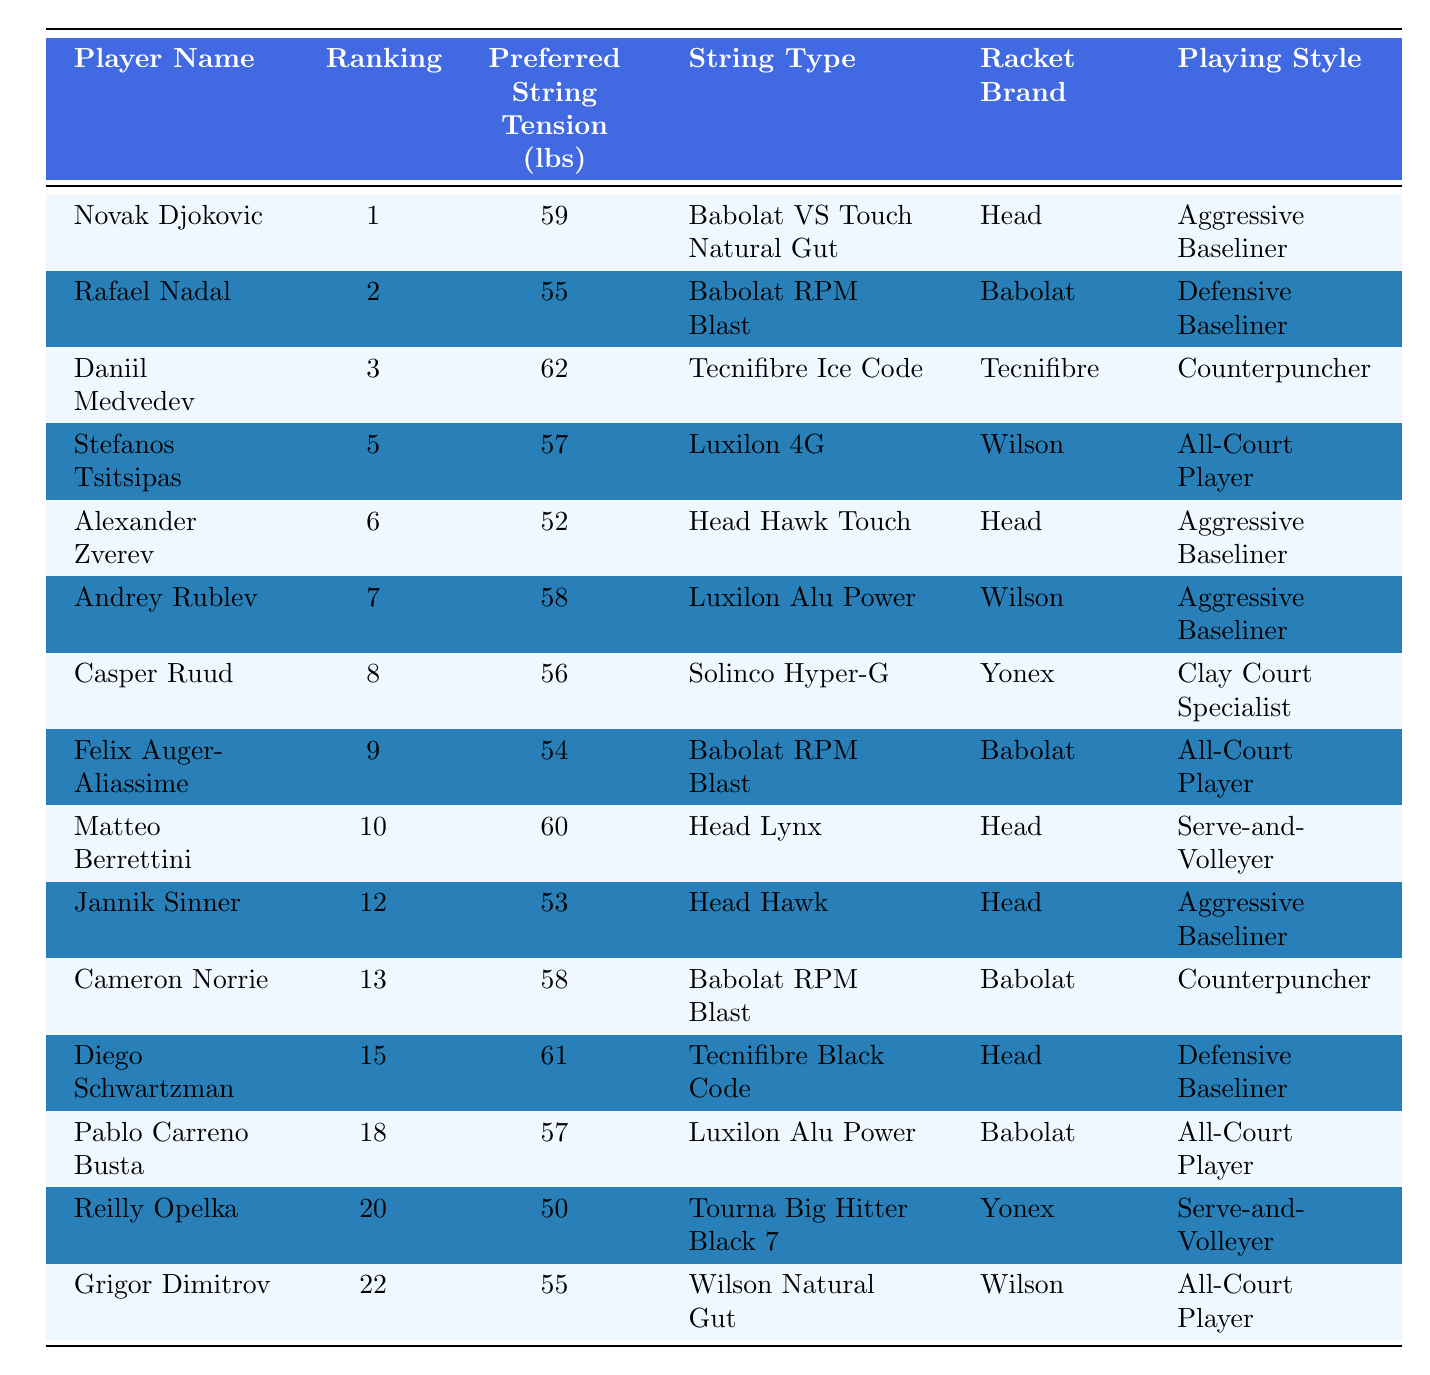What is the preferred string tension of Daniil Medvedev? According to the table, Daniil Medvedev's preferred string tension is listed as 62 lbs.
Answer: 62 lbs Which player has the highest string tension preference? By examining the "Preferred String Tension (lbs)" column, the highest value noted is 62 lbs, belonging to Daniil Medvedev.
Answer: Daniil Medvedev How many players prefer a string tension above 55 lbs? The players with string tensions above 55 lbs are Novak Djokovic (59 lbs), Daniil Medvedev (62 lbs), Andrey Rublev (58 lbs), Diego Schwartzman (61 lbs), and Matteo Berrettini (60 lbs). There are five players in total.
Answer: 5 Is Rafael Nadal a defensive baseliner? The table lists Rafael Nadal's playing style as "Defensive Baseliner." Thus, the statement is true.
Answer: Yes What is the preferred string tension difference between Alexander Zverev and Matteo Berrettini? Alexander Zverev has a preferred string tension of 52 lbs, while Matteo Berrettini has 60 lbs. The difference can be calculated as 60 - 52 = 8 lbs.
Answer: 8 lbs List the racket brands used by players with a preferred string tension above 55 lbs. Players with string tensions above 55 lbs are using the following racket brands: Head (Novak Djokovic, Daniil Medvedev, Matteo Berrettini, Diego Schwartzman), Wilson (Andrey Rublev, Stefanos Tsitsipas, Grigor Dimitrov), and Babolat (Cameron Norrie, Rafael Nadal, Pablo Carreno Busta). The unique brands are Head, Wilson, and Babolat.
Answer: Head, Wilson, Babolat How many players listed are serve-and-volleyers? The table identifies two players as serve-and-volleyers: Matteo Berrettini and Reilly Opelka.
Answer: 2 What is the average preferred string tension for all players? To calculate the average, you sum the string tensions (59 + 55 + 62 + 57 + 52 + 58 + 56 + 54 + 60 + 53 + 58 + 61 + 57 + 50 + 55) = 847 lbs and divide by the number of players (15), resulting in an average of 56.47 lbs.
Answer: 56.47 lbs Which playing style is most common among the players listed? By checking the "Playing Style" column, the "Aggressive Baseliner" style appears five times (Novak Djokovic, Alexander Zverev, Andrey Rublev, Jannik Sinner, and Grigor Dimitrov), while others appear less frequently. Thus, "Aggressive Baseliner" is the most common.
Answer: Aggressive Baseliner Is there any player associated with the racket brand Tecnifibre? In the table, Daniil Medvedev and Diego Schwartzman are both associated with the Tecnifibre brand. Thus, the statement is true.
Answer: Yes 